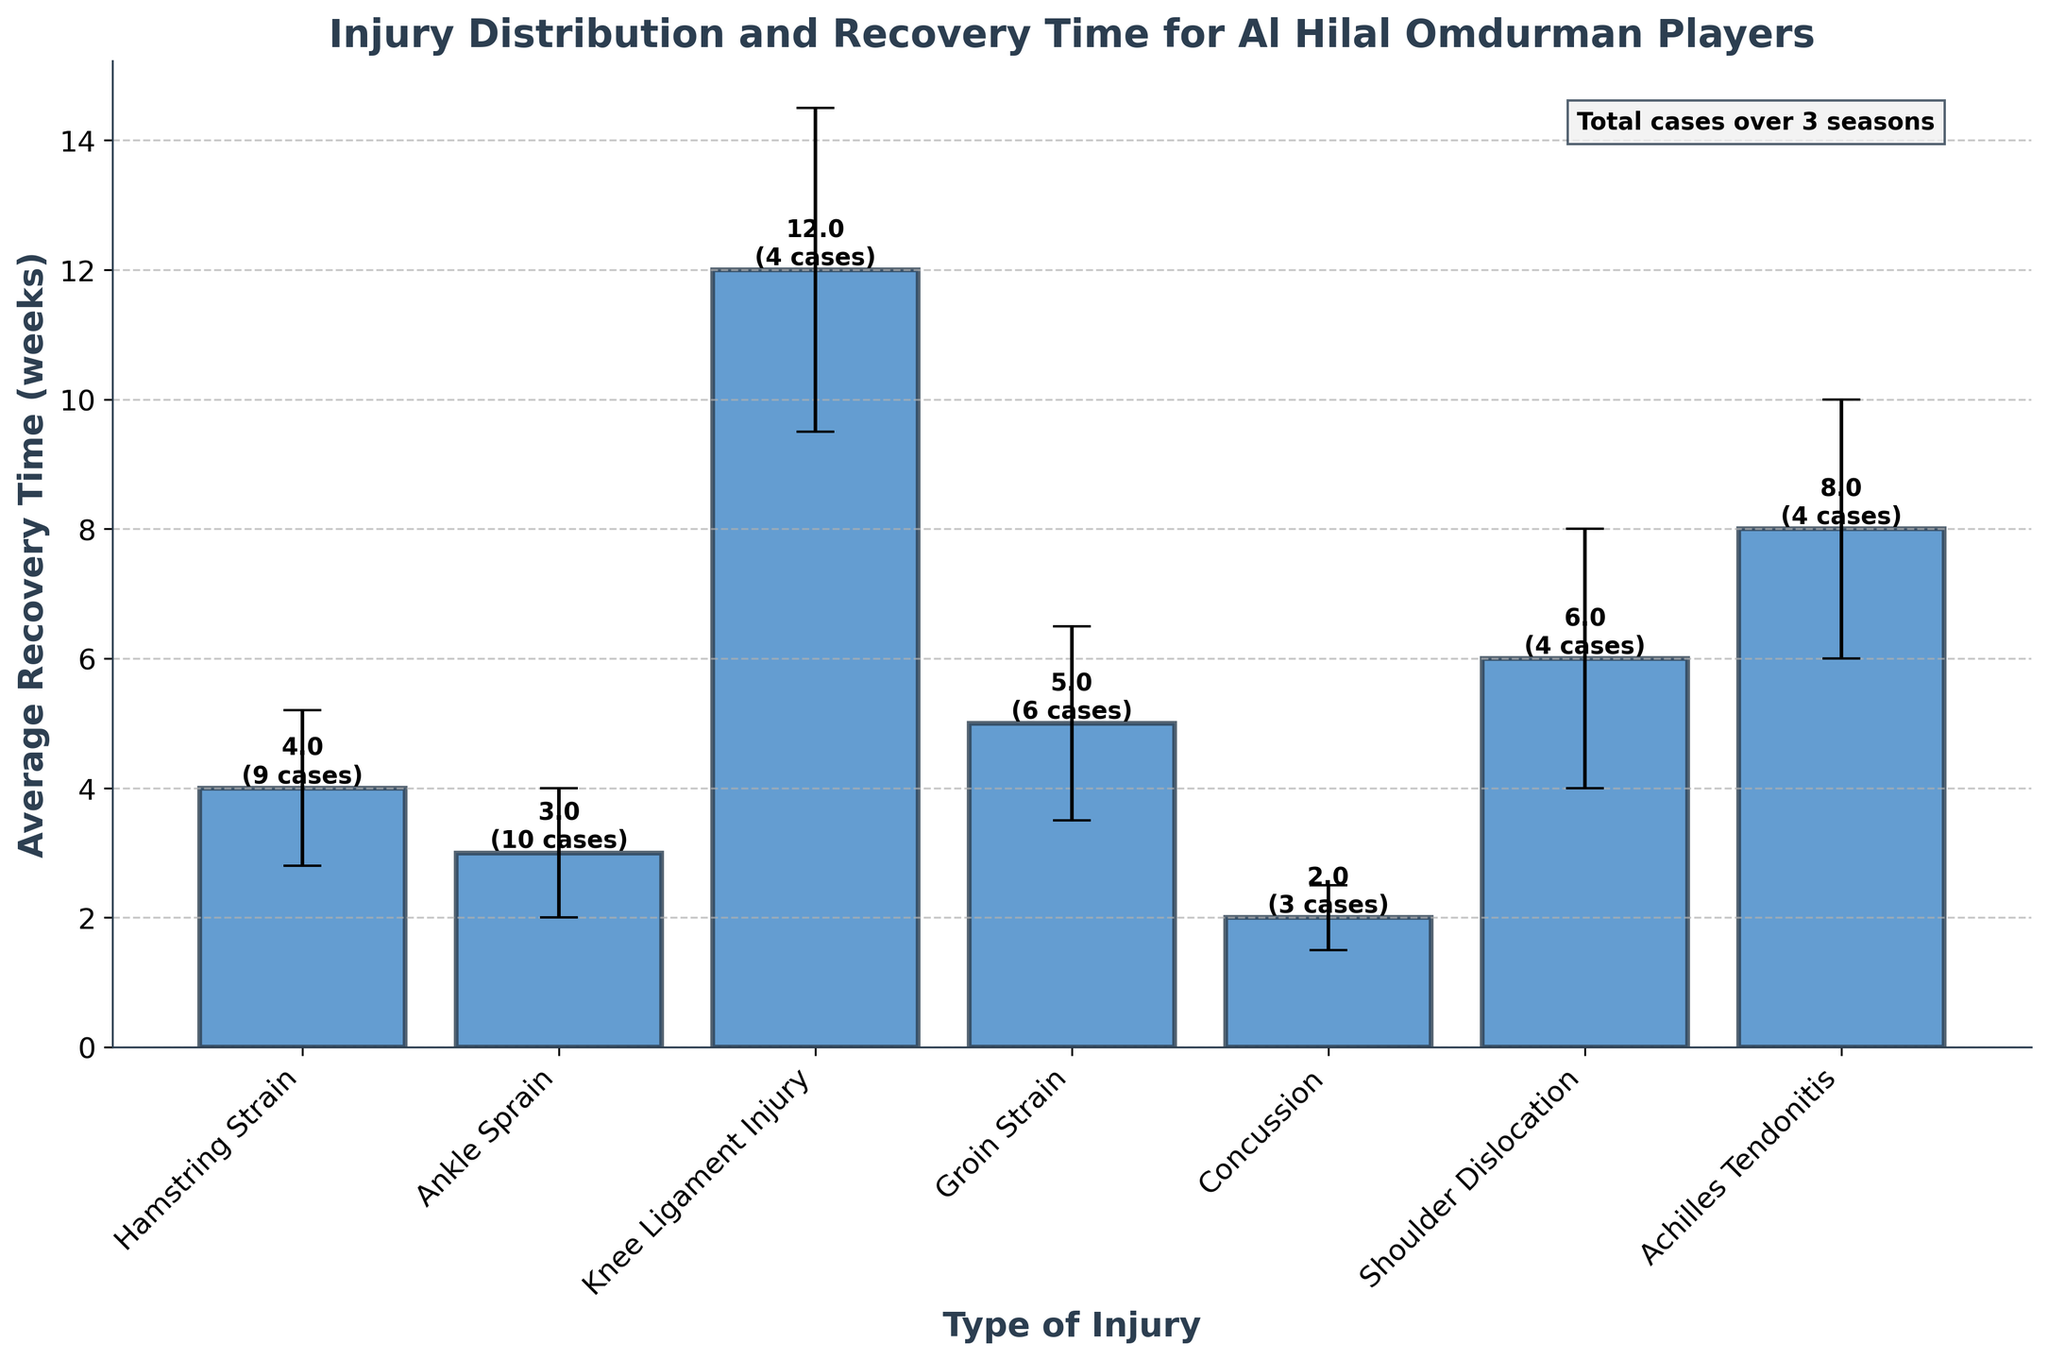What's the title of the figure? The title is usually located at the top part of the figure. In this case, the title is 'Injury Distribution and Recovery Time for Al Hilal Omdurman Players'.
Answer: Injury Distribution and Recovery Time for Al Hilal Omdurman Players What is the average recovery time for a hamstring strain? Look for the bar labeled 'Hamstring Strain' and read its height on the y-axis, which represents the average recovery time in weeks.
Answer: 4 weeks Which type of injury has the highest average recovery time? Identify the bar that reaches the highest point on the y-axis. The label of that bar is the type of injury with the highest average recovery time.
Answer: Knee Ligament Injury How many total cases of ankle sprain occurred over the three seasons? Find the bar labeled 'Ankle Sprain' and look for the total number of cases mentioned above the bar. It shows the sum of cases from the three seasons.
Answer: 10 cases Which injury type has the lowest variability in recovery time? The injury with the lowest variability will have the smallest error bars. Locate the bar with the shortest error bar (vertical line above/below the bar).
Answer: Concussion What is the average recovery time for shoulder dislocation? Look for the bar labeled 'Shoulder Dislocation' and read its height on the y-axis.
Answer: 6 weeks Which type of injury had the fewest cases over the three seasons? Check the total number of cases mentioned above each bar. The one with the smallest number indicates the fewest cases.
Answer: Concussion What's the total number of cases for groin strain across the three seasons? Sum the values provided for 'Groin Strain' across all three seasons and check the total noted above the corresponding bar.
Answer: 6 cases How does the average recovery time for an ankle sprain compare to that of a hamstring strain? Compare the heights of the bars for 'Ankle Sprain' and 'Hamstring Strain'. The bar with the lower height represents the injury with the shorter recovery time.
Answer: Ankle sprain recovery time is shorter For which type of injury is the variability in recovery time most significant? Determine which error bar (vertical line above/below the bar) is the longest. The label of that bar signifies the injury with the most significant variability.
Answer: Knee Ligament Injury 